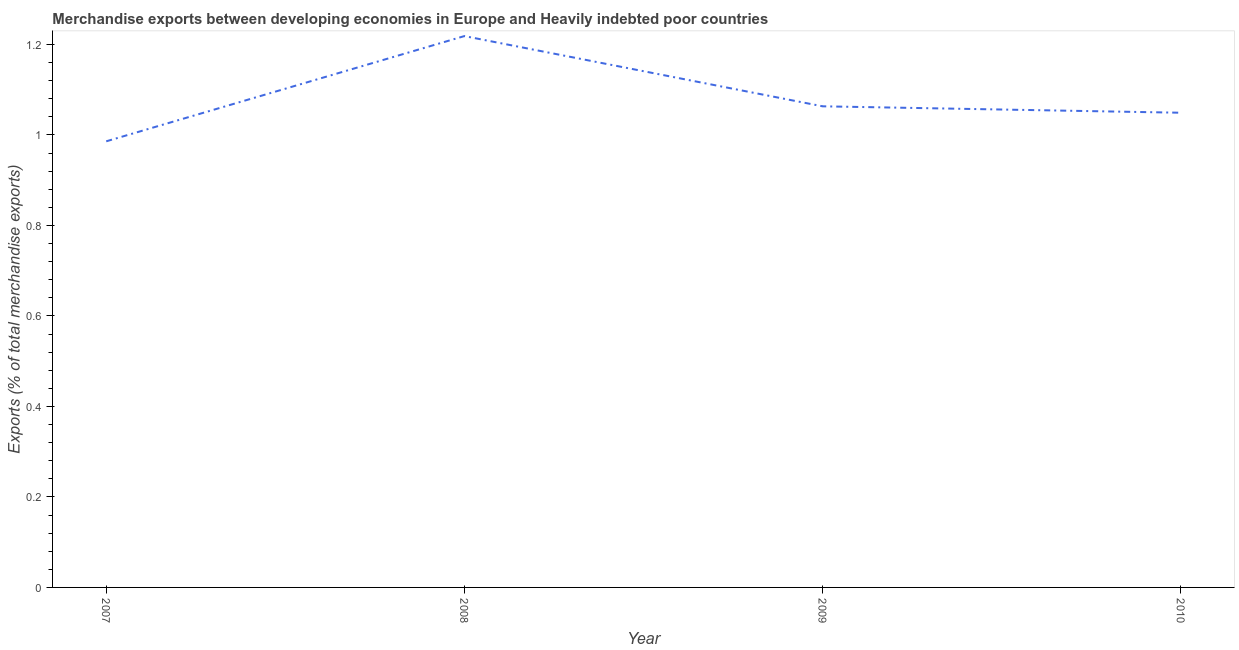What is the merchandise exports in 2007?
Provide a short and direct response. 0.99. Across all years, what is the maximum merchandise exports?
Make the answer very short. 1.22. Across all years, what is the minimum merchandise exports?
Give a very brief answer. 0.99. In which year was the merchandise exports minimum?
Give a very brief answer. 2007. What is the sum of the merchandise exports?
Offer a very short reply. 4.32. What is the difference between the merchandise exports in 2008 and 2010?
Give a very brief answer. 0.17. What is the average merchandise exports per year?
Keep it short and to the point. 1.08. What is the median merchandise exports?
Keep it short and to the point. 1.06. Do a majority of the years between 2009 and 2007 (inclusive) have merchandise exports greater than 0.56 %?
Offer a terse response. No. What is the ratio of the merchandise exports in 2008 to that in 2010?
Your answer should be very brief. 1.16. Is the merchandise exports in 2009 less than that in 2010?
Ensure brevity in your answer.  No. What is the difference between the highest and the second highest merchandise exports?
Your answer should be compact. 0.16. What is the difference between the highest and the lowest merchandise exports?
Make the answer very short. 0.23. Does the merchandise exports monotonically increase over the years?
Offer a terse response. No. What is the difference between two consecutive major ticks on the Y-axis?
Your response must be concise. 0.2. Are the values on the major ticks of Y-axis written in scientific E-notation?
Keep it short and to the point. No. What is the title of the graph?
Your answer should be compact. Merchandise exports between developing economies in Europe and Heavily indebted poor countries. What is the label or title of the Y-axis?
Provide a short and direct response. Exports (% of total merchandise exports). What is the Exports (% of total merchandise exports) of 2007?
Give a very brief answer. 0.99. What is the Exports (% of total merchandise exports) in 2008?
Provide a short and direct response. 1.22. What is the Exports (% of total merchandise exports) in 2009?
Give a very brief answer. 1.06. What is the Exports (% of total merchandise exports) of 2010?
Keep it short and to the point. 1.05. What is the difference between the Exports (% of total merchandise exports) in 2007 and 2008?
Your answer should be very brief. -0.23. What is the difference between the Exports (% of total merchandise exports) in 2007 and 2009?
Keep it short and to the point. -0.08. What is the difference between the Exports (% of total merchandise exports) in 2007 and 2010?
Make the answer very short. -0.06. What is the difference between the Exports (% of total merchandise exports) in 2008 and 2009?
Your answer should be compact. 0.16. What is the difference between the Exports (% of total merchandise exports) in 2008 and 2010?
Offer a very short reply. 0.17. What is the difference between the Exports (% of total merchandise exports) in 2009 and 2010?
Keep it short and to the point. 0.01. What is the ratio of the Exports (% of total merchandise exports) in 2007 to that in 2008?
Offer a terse response. 0.81. What is the ratio of the Exports (% of total merchandise exports) in 2007 to that in 2009?
Provide a short and direct response. 0.93. What is the ratio of the Exports (% of total merchandise exports) in 2008 to that in 2009?
Your answer should be compact. 1.15. What is the ratio of the Exports (% of total merchandise exports) in 2008 to that in 2010?
Your answer should be compact. 1.16. What is the ratio of the Exports (% of total merchandise exports) in 2009 to that in 2010?
Your response must be concise. 1.01. 